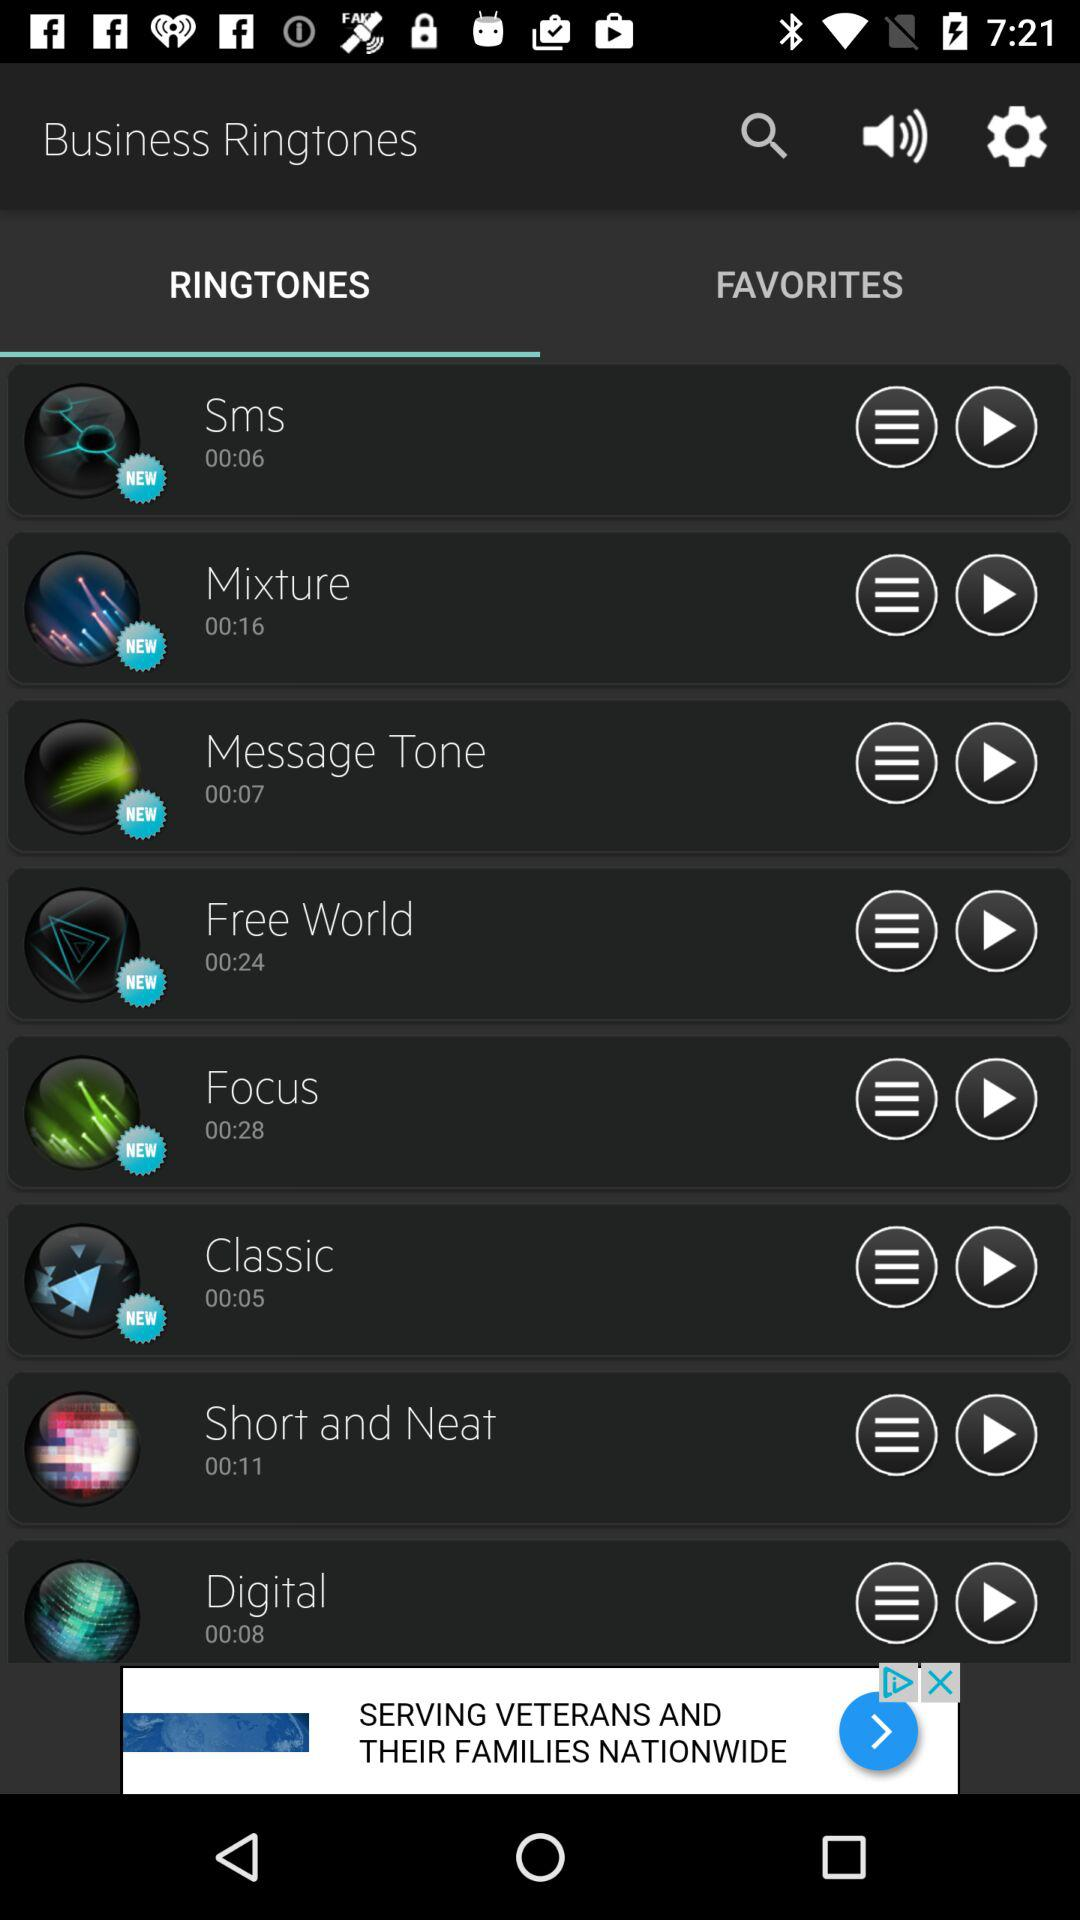What is the duration of the ringtone "Mixture"? The duration is 16 seconds. 